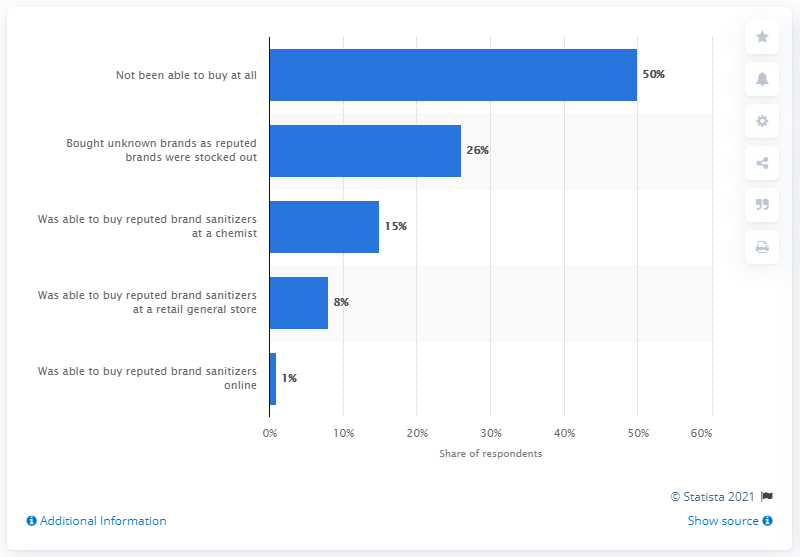Draw attention to some important aspects in this diagram. The most popular reason for not being able to buy was not being able to buy at all. The two most popular reasons combined accounted for a total of 76%. According to the survey, 26% of Indians purchased hand sanitizers from unknown brands. 